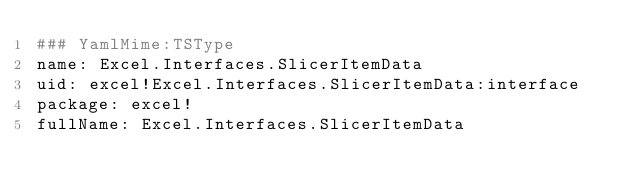Convert code to text. <code><loc_0><loc_0><loc_500><loc_500><_YAML_>### YamlMime:TSType
name: Excel.Interfaces.SlicerItemData
uid: excel!Excel.Interfaces.SlicerItemData:interface
package: excel!
fullName: Excel.Interfaces.SlicerItemData</code> 